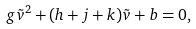Convert formula to latex. <formula><loc_0><loc_0><loc_500><loc_500>g \tilde { v } ^ { 2 } + ( h + j + k ) \tilde { v } + b = 0 ,</formula> 